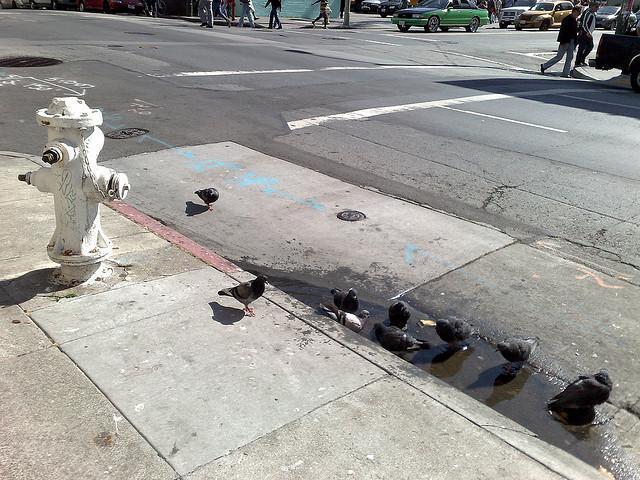How many birds?
Give a very brief answer. 9. How many motorcycles are there?
Give a very brief answer. 0. 